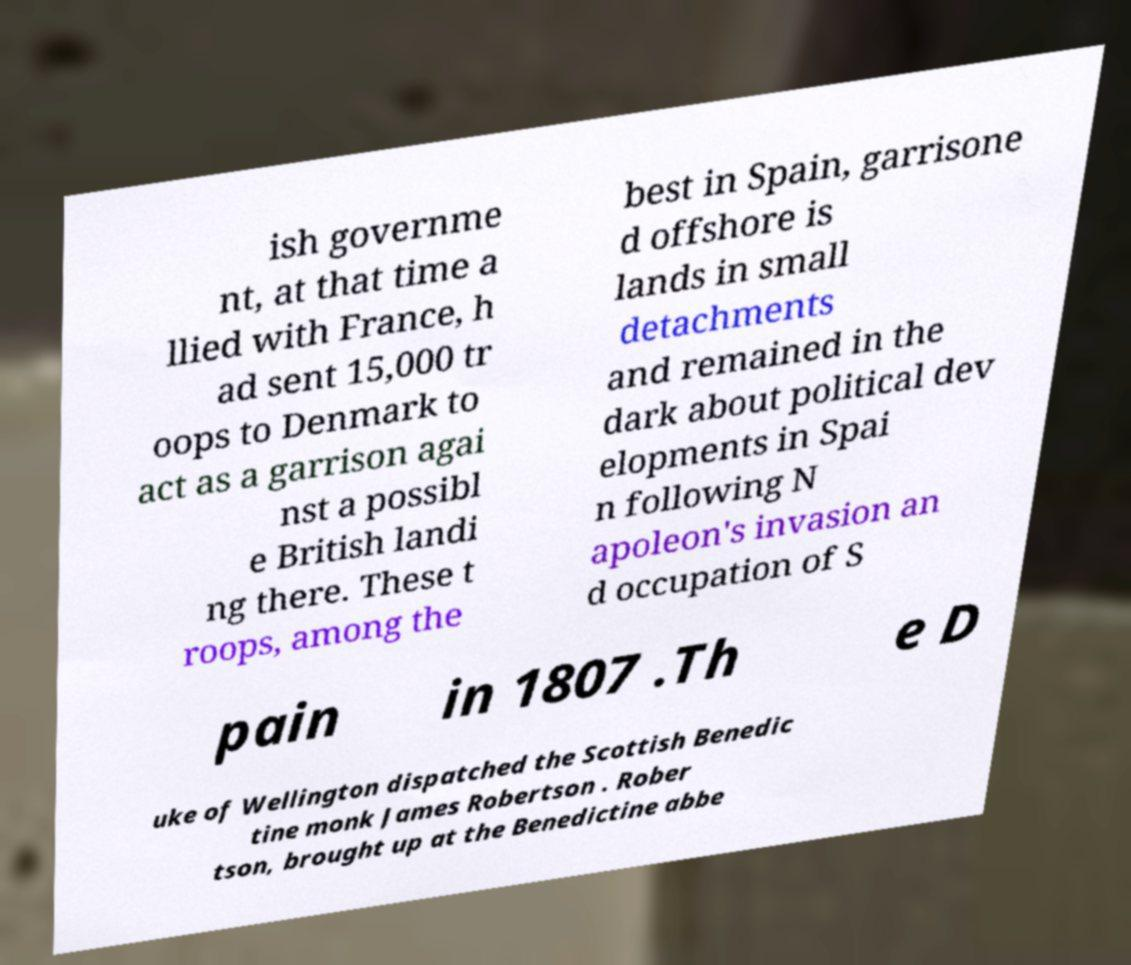Could you extract and type out the text from this image? ish governme nt, at that time a llied with France, h ad sent 15,000 tr oops to Denmark to act as a garrison agai nst a possibl e British landi ng there. These t roops, among the best in Spain, garrisone d offshore is lands in small detachments and remained in the dark about political dev elopments in Spai n following N apoleon's invasion an d occupation of S pain in 1807 .Th e D uke of Wellington dispatched the Scottish Benedic tine monk James Robertson . Rober tson, brought up at the Benedictine abbe 